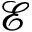<formula> <loc_0><loc_0><loc_500><loc_500>\mathcal { E }</formula> 